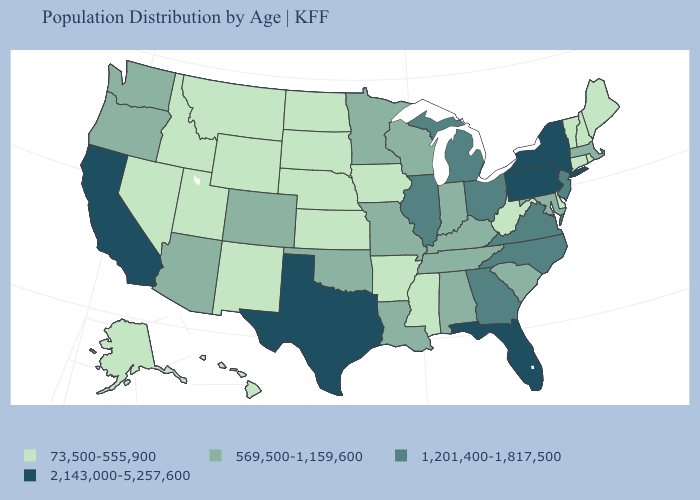Name the states that have a value in the range 73,500-555,900?
Give a very brief answer. Alaska, Arkansas, Connecticut, Delaware, Hawaii, Idaho, Iowa, Kansas, Maine, Mississippi, Montana, Nebraska, Nevada, New Hampshire, New Mexico, North Dakota, Rhode Island, South Dakota, Utah, Vermont, West Virginia, Wyoming. What is the lowest value in states that border Wisconsin?
Give a very brief answer. 73,500-555,900. What is the highest value in the USA?
Concise answer only. 2,143,000-5,257,600. What is the value of Missouri?
Quick response, please. 569,500-1,159,600. Name the states that have a value in the range 73,500-555,900?
Keep it brief. Alaska, Arkansas, Connecticut, Delaware, Hawaii, Idaho, Iowa, Kansas, Maine, Mississippi, Montana, Nebraska, Nevada, New Hampshire, New Mexico, North Dakota, Rhode Island, South Dakota, Utah, Vermont, West Virginia, Wyoming. Does Pennsylvania have the highest value in the USA?
Quick response, please. Yes. What is the lowest value in the USA?
Concise answer only. 73,500-555,900. What is the value of Indiana?
Short answer required. 569,500-1,159,600. Which states hav the highest value in the South?
Write a very short answer. Florida, Texas. What is the highest value in the West ?
Give a very brief answer. 2,143,000-5,257,600. What is the value of Virginia?
Be succinct. 1,201,400-1,817,500. Does Tennessee have a higher value than Kentucky?
Give a very brief answer. No. What is the value of Florida?
Keep it brief. 2,143,000-5,257,600. Does Maryland have the highest value in the USA?
Answer briefly. No. What is the lowest value in states that border Nebraska?
Concise answer only. 73,500-555,900. 